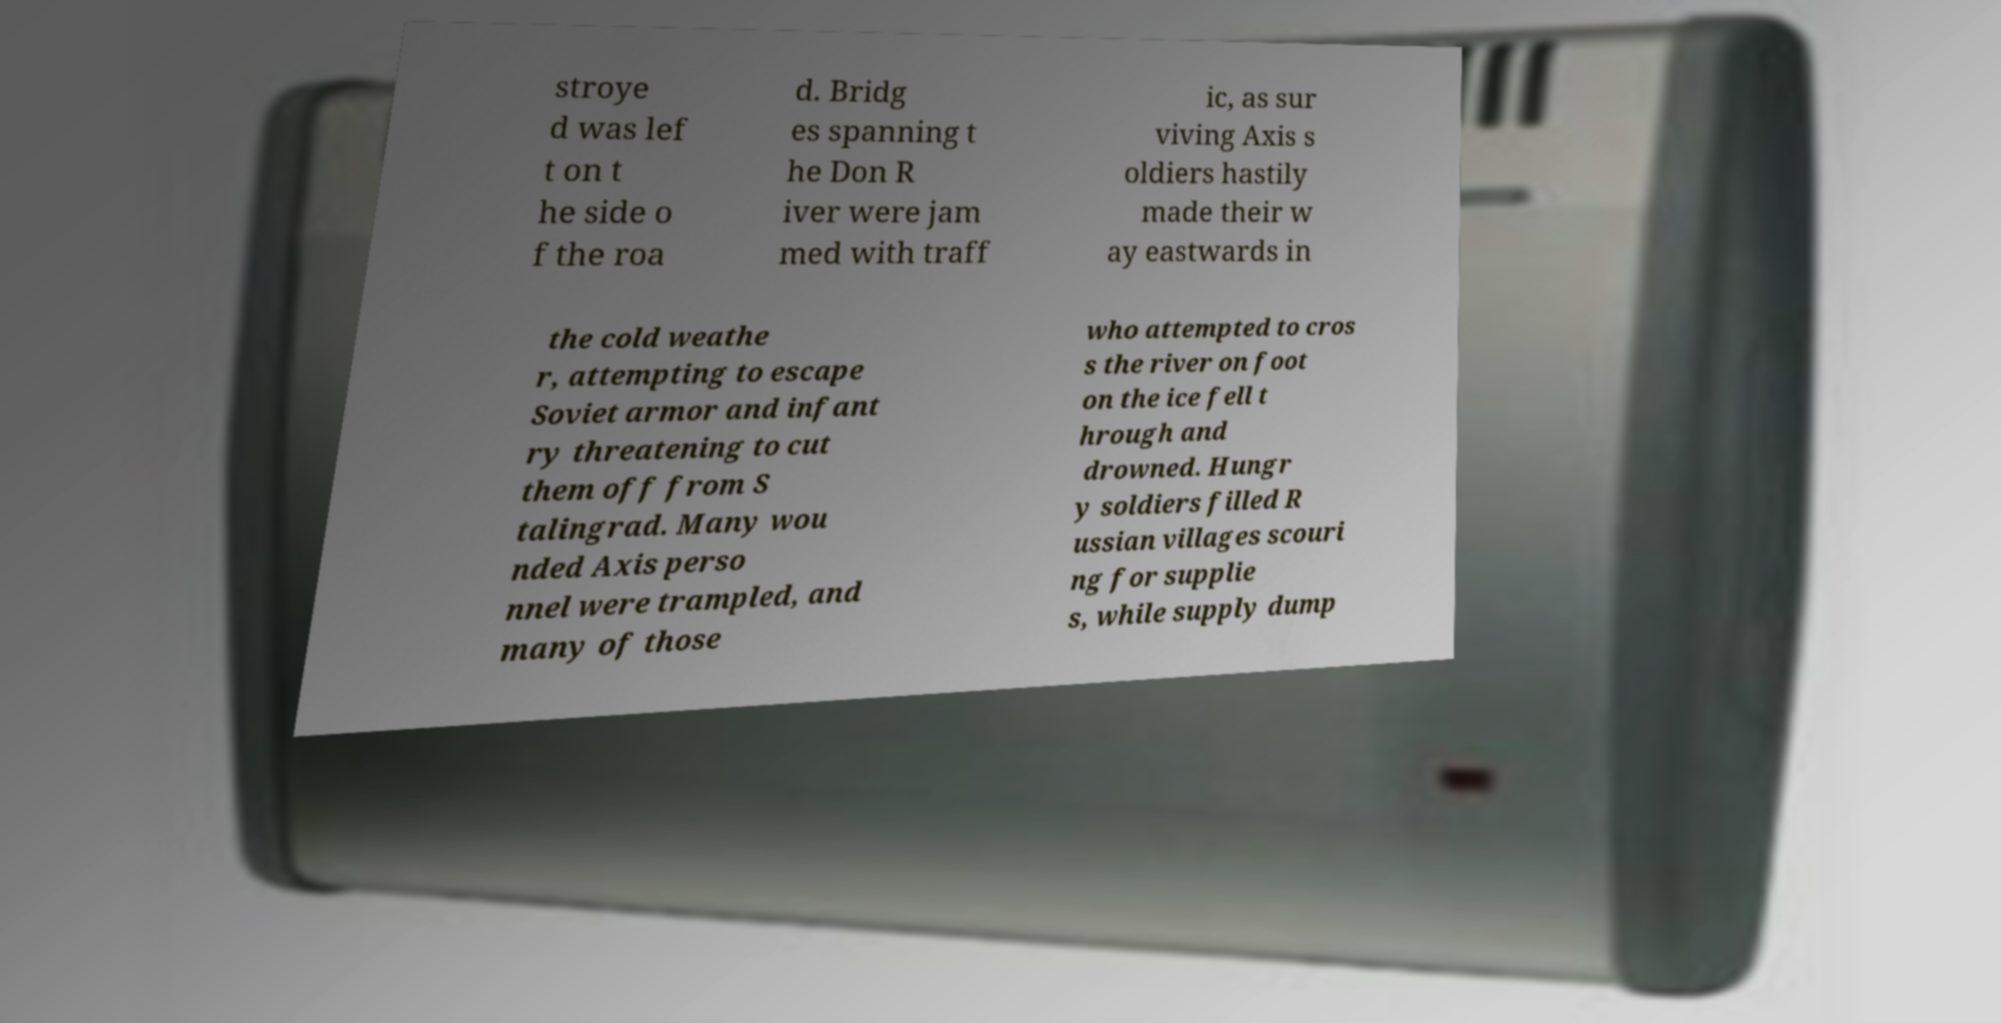Can you accurately transcribe the text from the provided image for me? stroye d was lef t on t he side o f the roa d. Bridg es spanning t he Don R iver were jam med with traff ic, as sur viving Axis s oldiers hastily made their w ay eastwards in the cold weathe r, attempting to escape Soviet armor and infant ry threatening to cut them off from S talingrad. Many wou nded Axis perso nnel were trampled, and many of those who attempted to cros s the river on foot on the ice fell t hrough and drowned. Hungr y soldiers filled R ussian villages scouri ng for supplie s, while supply dump 